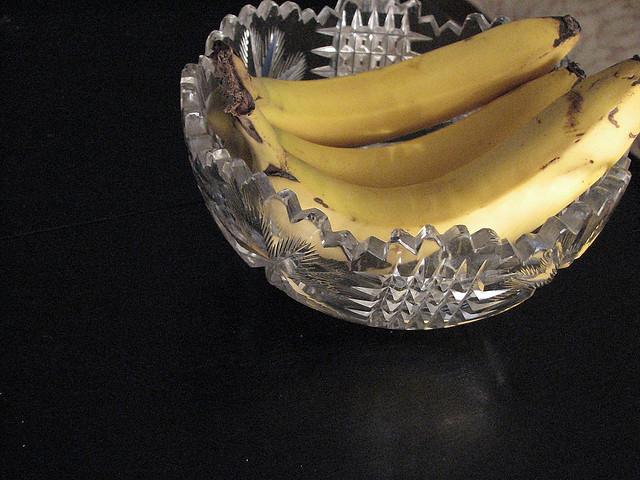What color is the bananas?
Quick response, please. Yellow. Is one banana longer?
Quick response, please. Yes. What is the object?
Give a very brief answer. Bananas. Are the bananas peeled?
Answer briefly. No. 